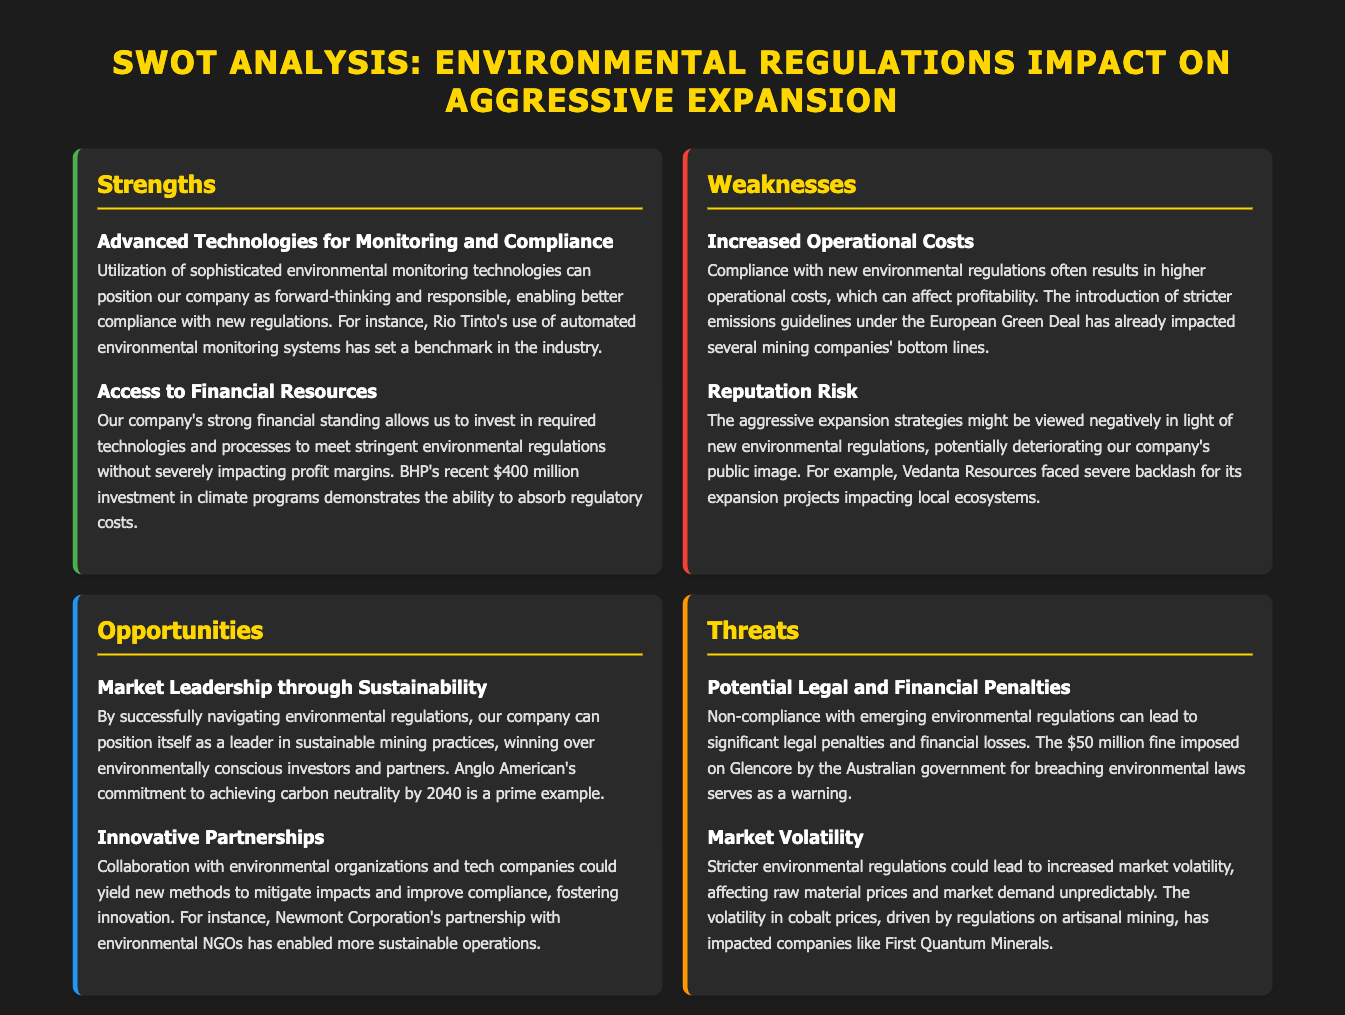What is a strength regarding technologies? The strength highlights the use of sophisticated environmental monitoring technologies that can enhance compliance with regulations.
Answer: Advanced Technologies for Monitoring and Compliance What significant investment example is mentioned? The document references a specific investment that exemplifies financial capability amidst regulatory challenges.
Answer: $400 million Which company faced backlash for its expansion projects? The document provides an example of a company negatively impacted due to aggressive expansion in relation to environmental concerns.
Answer: Vedanta Resources What is one opportunity for the company mentioned? The document states an opportunity related to market positioning through sustainable practices amidst regulations.
Answer: Market Leadership through Sustainability What threat involves legal consequences? The document identifies a risk tied to non-compliance with regulations that can affect finances and operations.
Answer: Potential Legal and Financial Penalties How much was the fine imposed on Glencore? The document states a specific amount related to a penalty for environmental law breaches.
Answer: $50 million What is a potential impact of environmental regulations on the market? The document outlines a risk that suggests unpredictability in market conditions due to regulation.
Answer: Market Volatility Which mining company's partnership with NGOs is highlighted? The document mentions a collaboration that enhances sustainability in mining operations.
Answer: Newmont Corporation 